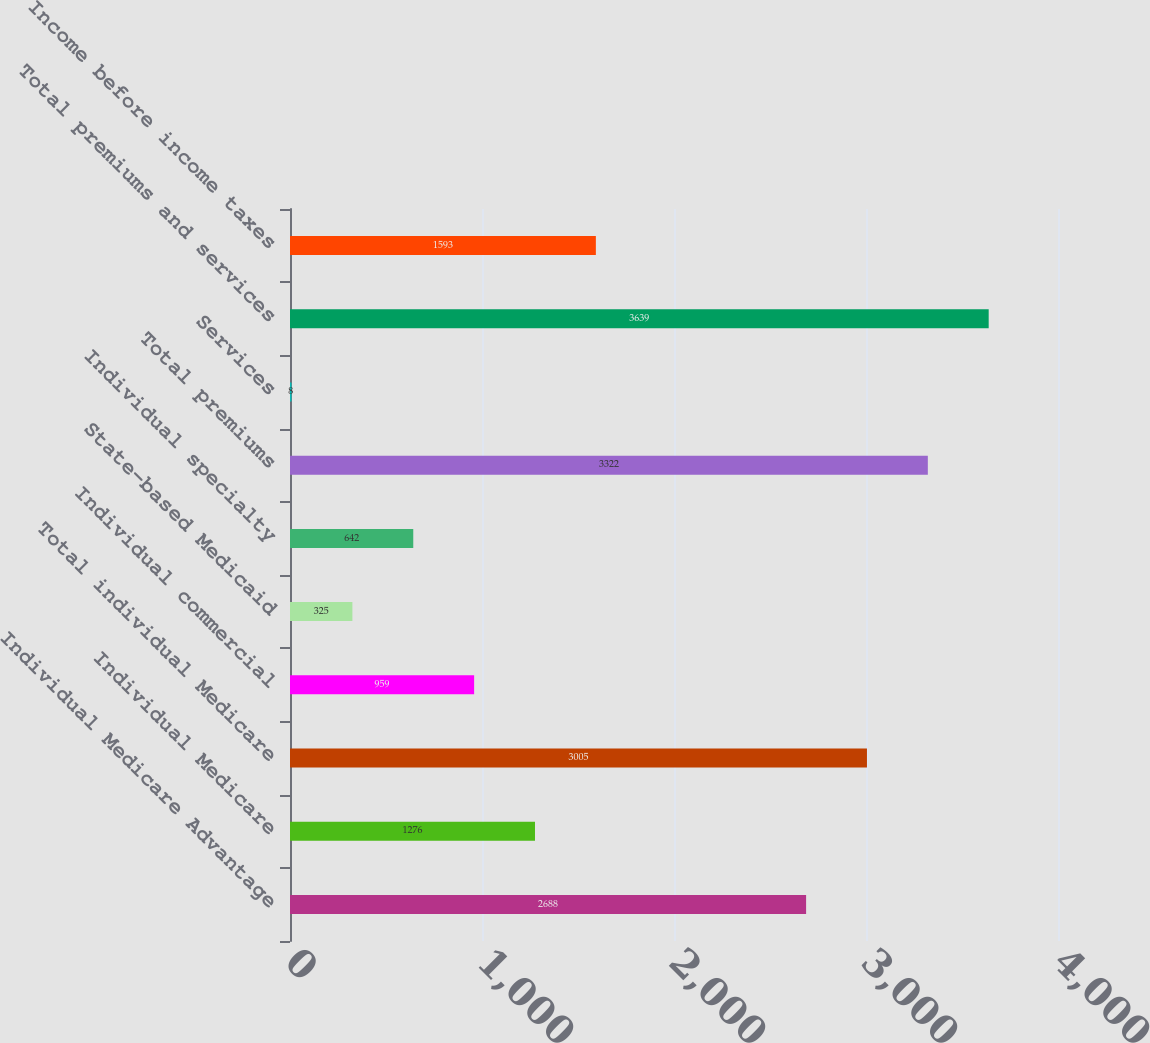Convert chart to OTSL. <chart><loc_0><loc_0><loc_500><loc_500><bar_chart><fcel>Individual Medicare Advantage<fcel>Individual Medicare<fcel>Total individual Medicare<fcel>Individual commercial<fcel>State-based Medicaid<fcel>Individual specialty<fcel>Total premiums<fcel>Services<fcel>Total premiums and services<fcel>Income before income taxes<nl><fcel>2688<fcel>1276<fcel>3005<fcel>959<fcel>325<fcel>642<fcel>3322<fcel>8<fcel>3639<fcel>1593<nl></chart> 